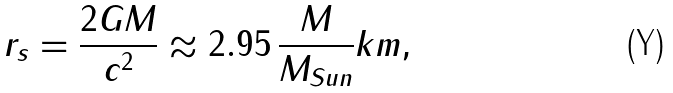<formula> <loc_0><loc_0><loc_500><loc_500>r _ { s } = { \frac { 2 G M } { c ^ { 2 } } } \approx 2 . 9 5 \, { \frac { M } { M _ { S u n } } } k m ,</formula> 